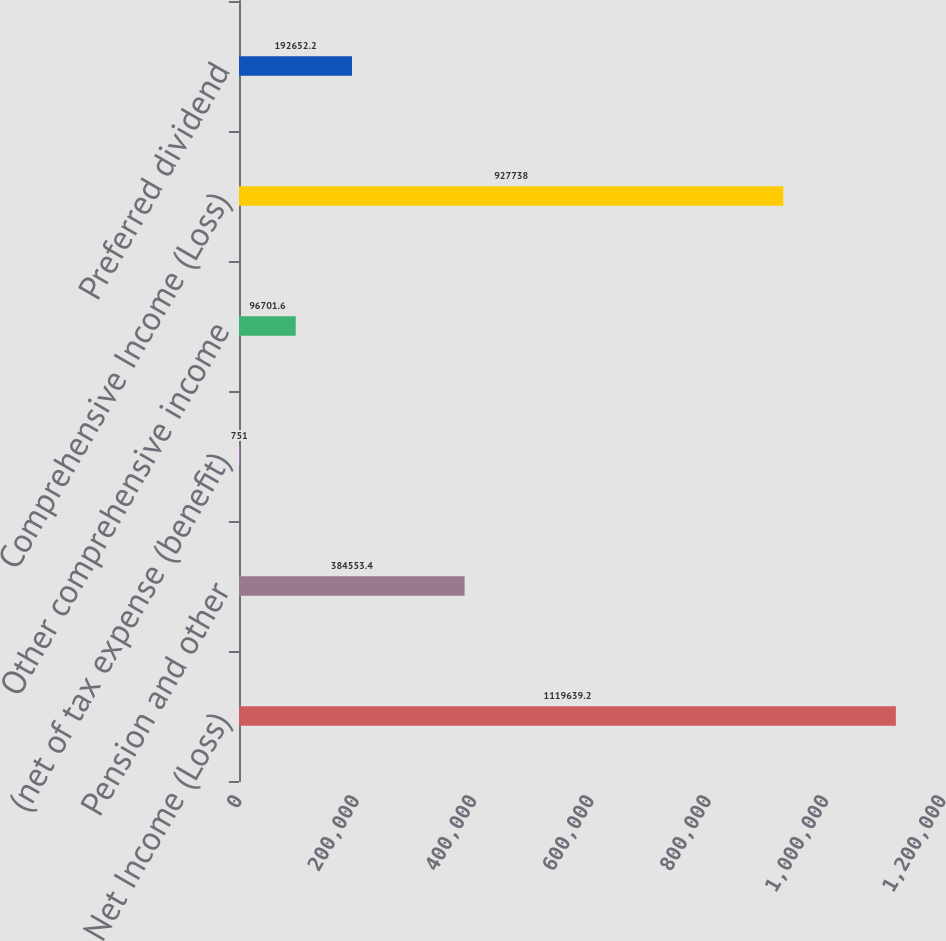Convert chart to OTSL. <chart><loc_0><loc_0><loc_500><loc_500><bar_chart><fcel>Net Income (Loss)<fcel>Pension and other<fcel>(net of tax expense (benefit)<fcel>Other comprehensive income<fcel>Comprehensive Income (Loss)<fcel>Preferred dividend<nl><fcel>1.11964e+06<fcel>384553<fcel>751<fcel>96701.6<fcel>927738<fcel>192652<nl></chart> 